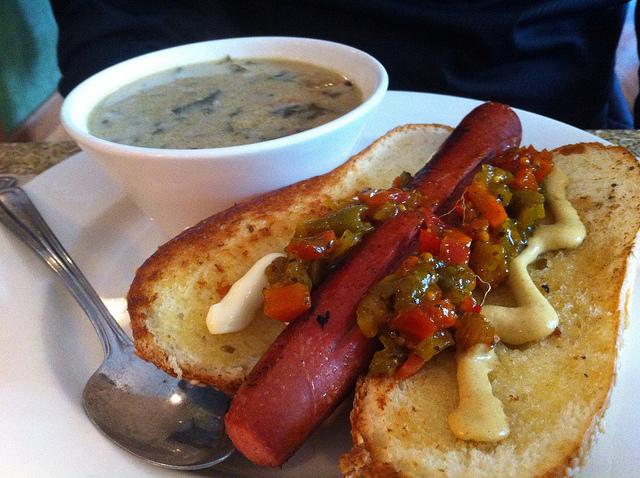Is this a hot dog?
Concise answer only. Yes. Is there a soup bowl next to the hot dog?
Short answer required. Yes. Are there any condiments on the hot dog?
Give a very brief answer. Yes. 